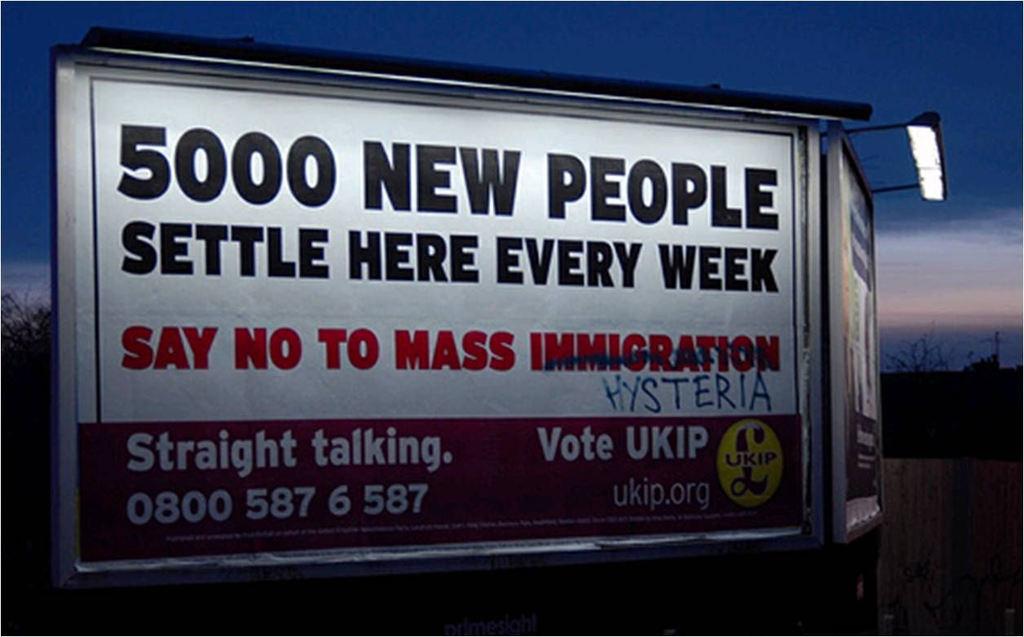What does the billboard want people to vote?
Offer a very short reply. Ukip. How many people are mentioned?
Your answer should be compact. 5000. 